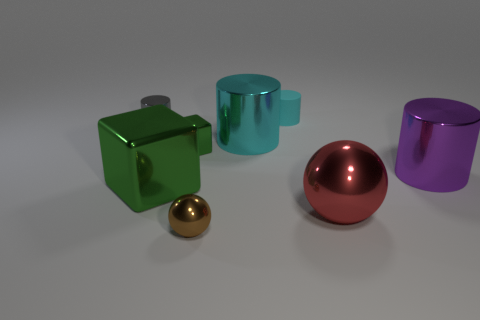There is a big thing that is both left of the cyan rubber thing and behind the big green thing; what material is it?
Offer a terse response. Metal. There is a tiny cylinder behind the metal cylinder that is to the left of the metallic cube in front of the big purple cylinder; what is its color?
Offer a terse response. Cyan. What number of yellow objects are matte objects or big blocks?
Offer a very short reply. 0. What number of other things are the same size as the brown metal sphere?
Make the answer very short. 3. What number of tiny cyan cylinders are there?
Make the answer very short. 1. Is there any other thing that has the same shape as the small green metallic object?
Make the answer very short. Yes. Do the cylinder behind the gray metal cylinder and the thing that is to the right of the large red object have the same material?
Give a very brief answer. No. What is the material of the tiny gray cylinder?
Keep it short and to the point. Metal. What number of small spheres are made of the same material as the brown object?
Give a very brief answer. 0. What number of matte objects are either big blue cylinders or blocks?
Make the answer very short. 0. 